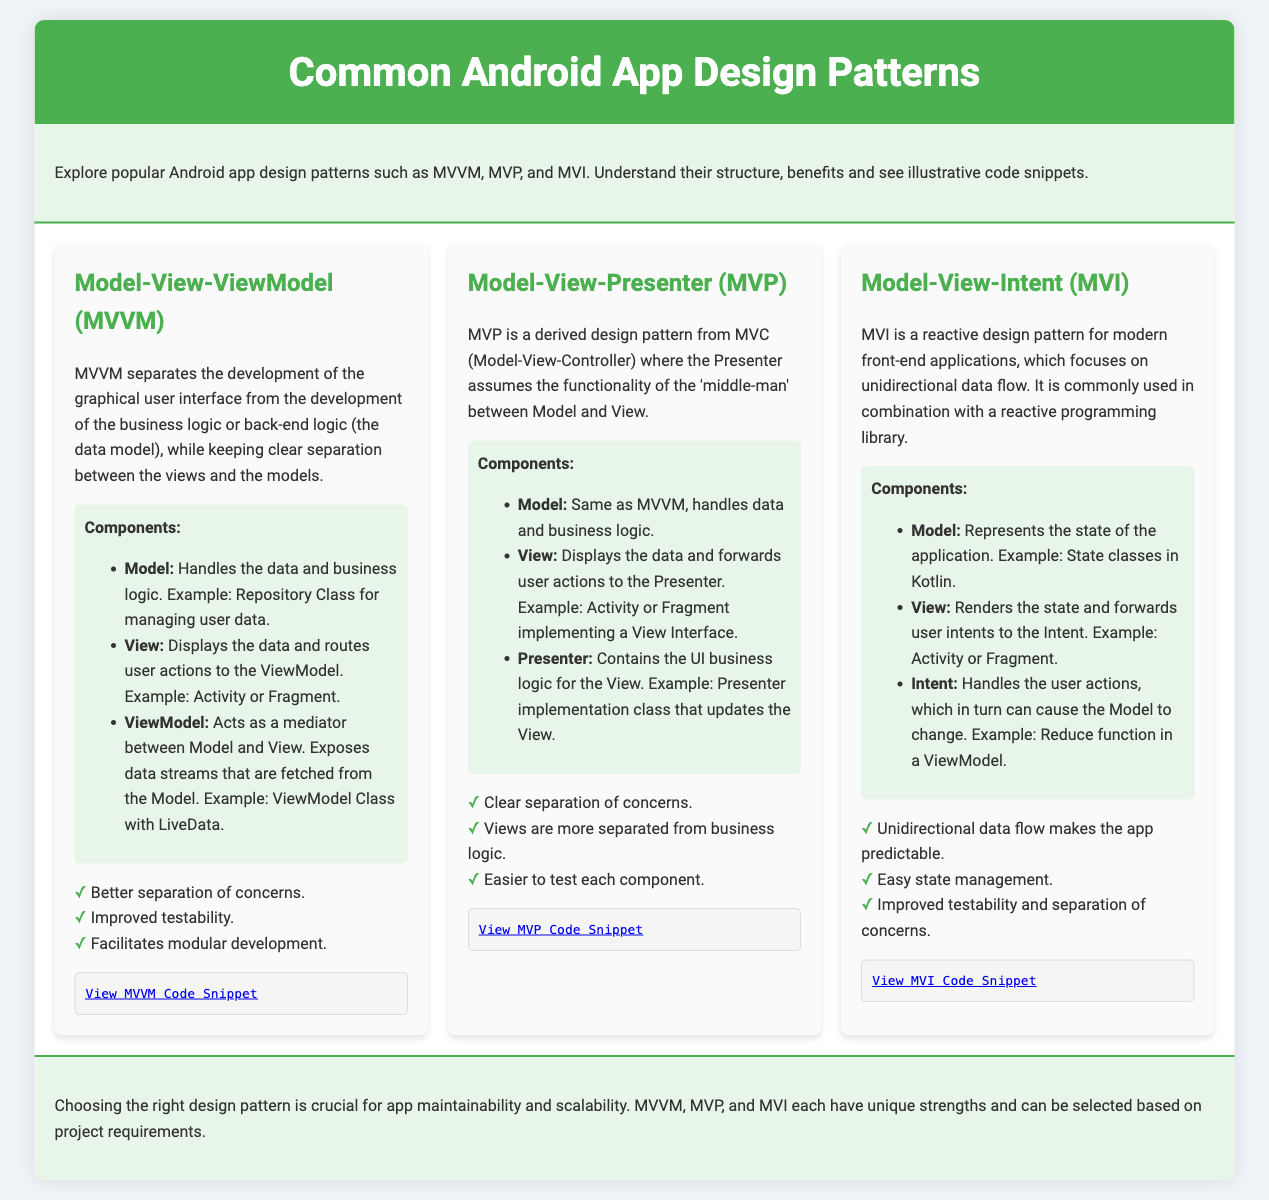What is the name of the first design pattern mentioned? The first design pattern outlined in the document is titled "Model-View-ViewModel (MVVM)."
Answer: Model-View-ViewModel (MVVM) What are the components of MVP? The components of MVP include Model, View, and Presenter as listed in the document.
Answer: Model, View, Presenter What are the benefits of MVI? The document highlights three specific benefits of MVI, which include unidirectional data flow, easy state management, and improved testability.
Answer: Unidirectional data flow, easy state management, improved testability Which design pattern facilitates modular development? The document states that "MVVM" facilitates modular development among its benefits.
Answer: MVVM How many design patterns are discussed in total? The document discusses three design patterns: MVVM, MVP, and MVI, making the total three.
Answer: Three What does ViewModel do in MVVM? According to the document, the ViewModel acts as a mediator between the Model and View.
Answer: Mediator between Model and View What is the main focus of MVI? The document states that MVI focuses on unidirectional data flow.
Answer: Unidirectional data flow Which design pattern is described as a reactive design pattern? The document specifies that MVI is a reactive design pattern for modern front-end applications.
Answer: MVI 